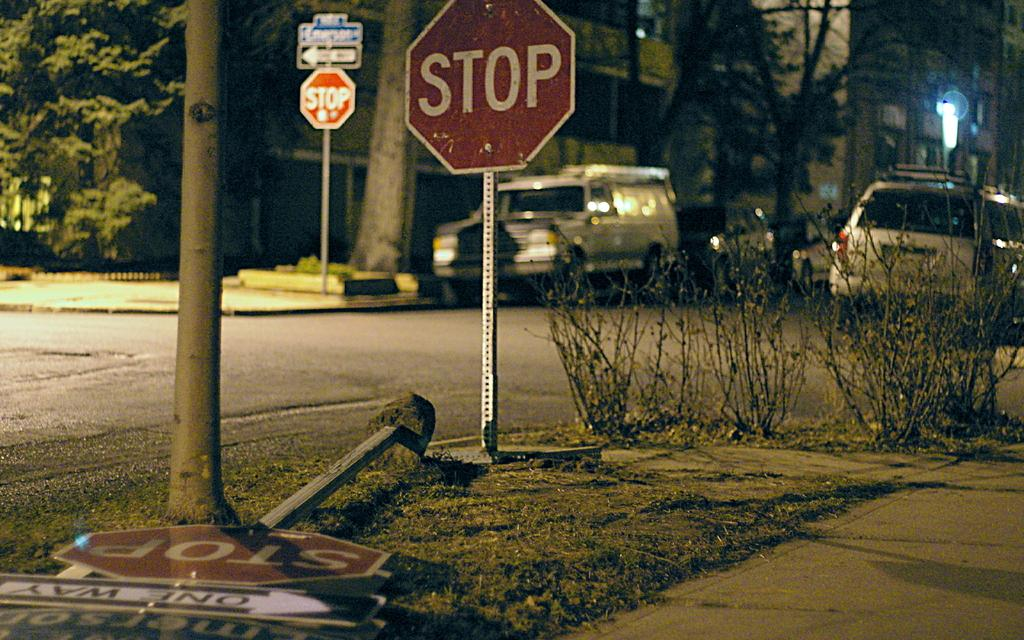<image>
Present a compact description of the photo's key features. a stop sign that is outside with cars around 